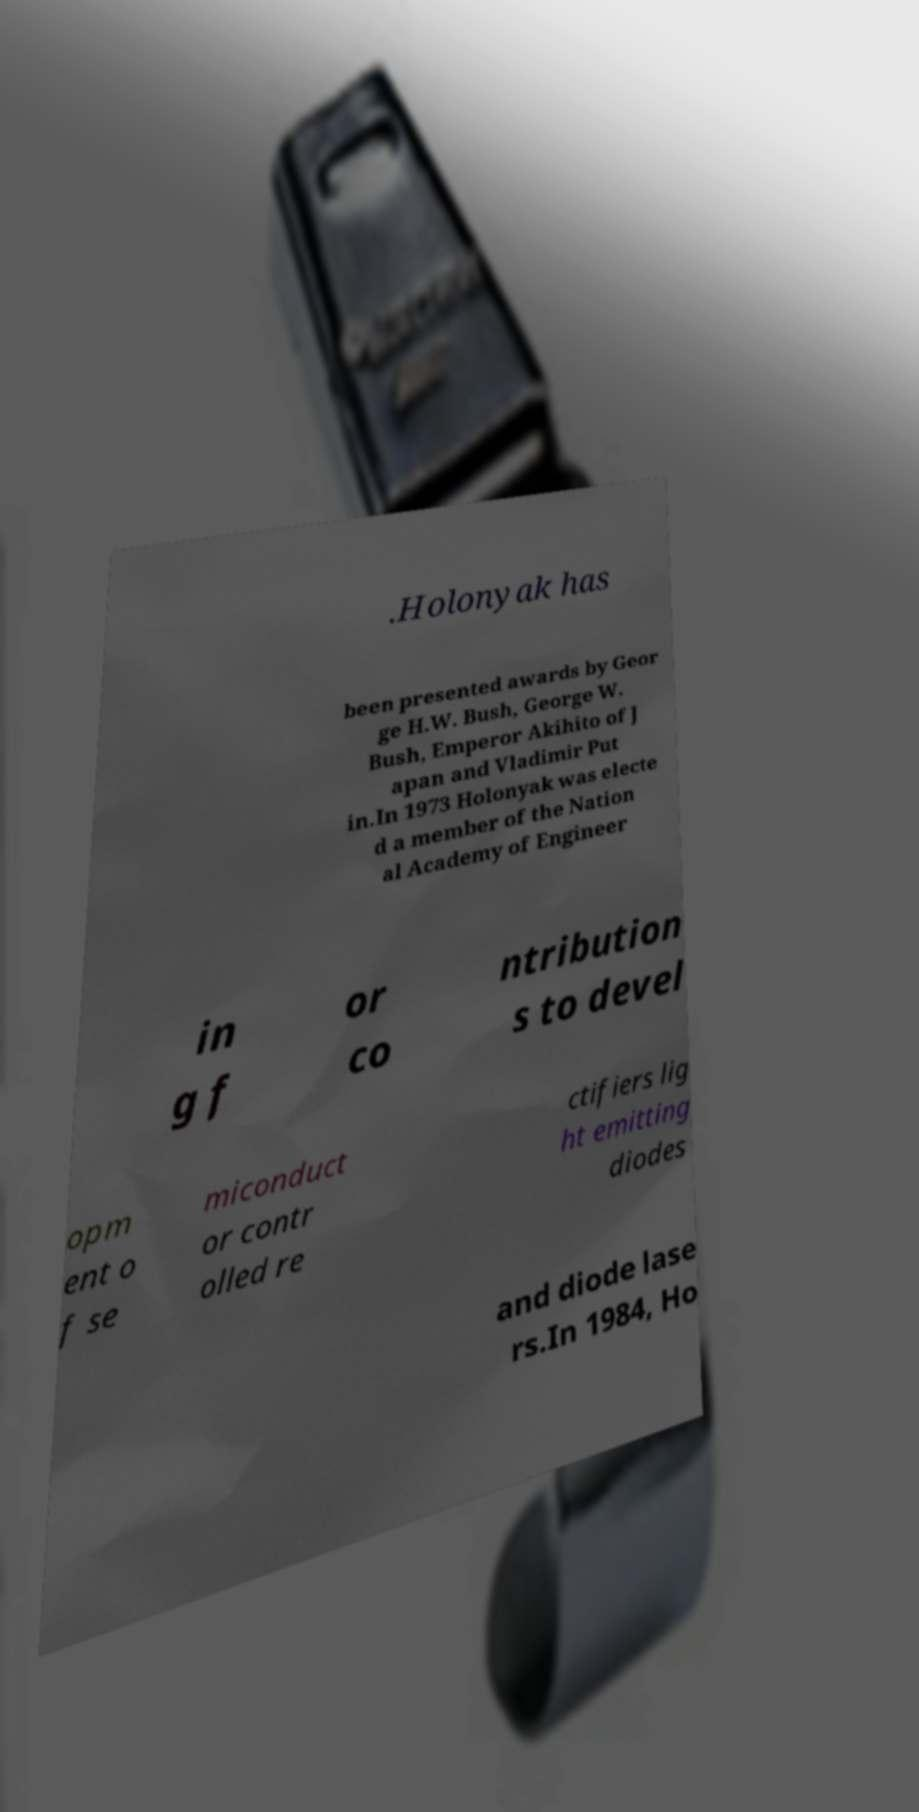Could you extract and type out the text from this image? .Holonyak has been presented awards by Geor ge H.W. Bush, George W. Bush, Emperor Akihito of J apan and Vladimir Put in.In 1973 Holonyak was electe d a member of the Nation al Academy of Engineer in g f or co ntribution s to devel opm ent o f se miconduct or contr olled re ctifiers lig ht emitting diodes and diode lase rs.In 1984, Ho 